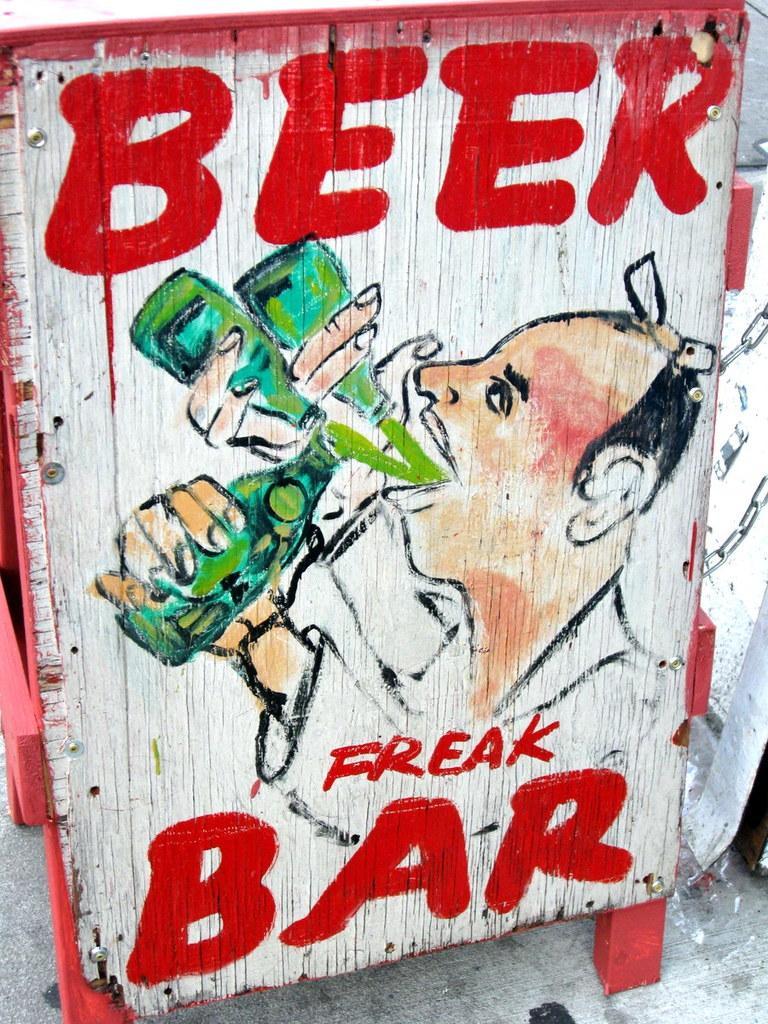In one or two sentences, can you explain what this image depicts? This image consists of a box made up of wood. On which there is a man drinking beer. And there is a text. 